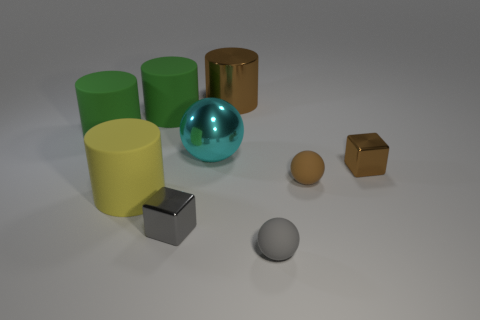Add 1 green cylinders. How many objects exist? 10 Subtract all cubes. How many objects are left? 7 Add 8 tiny matte balls. How many tiny matte balls exist? 10 Subtract 1 gray blocks. How many objects are left? 8 Subtract all large metal objects. Subtract all shiny blocks. How many objects are left? 5 Add 2 brown metal cylinders. How many brown metal cylinders are left? 3 